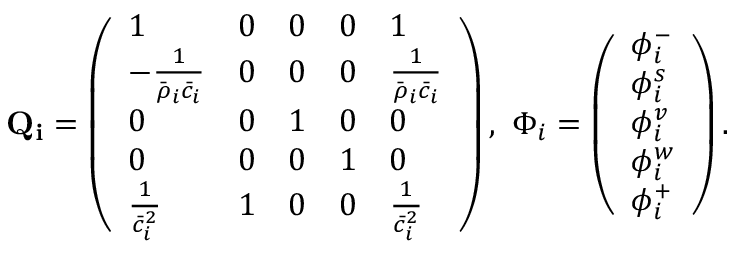<formula> <loc_0><loc_0><loc_500><loc_500>Q _ { i } = \left ( \begin{array} { l l l l l } { 1 } & { 0 } & { 0 } & { 0 } & { 1 } \\ { - \frac { 1 } { \bar { \rho } _ { i } \bar { c } _ { i } } } & { 0 } & { 0 } & { 0 } & { \frac { 1 } { \bar { \rho } _ { i } \bar { c } _ { i } } } \\ { 0 } & { 0 } & { 1 } & { 0 } & { 0 } \\ { 0 } & { 0 } & { 0 } & { 1 } & { 0 } \\ { \frac { 1 } { \bar { c } _ { i } ^ { 2 } } } & { 1 } & { 0 } & { 0 } & { \frac { 1 } { \bar { c } _ { i } ^ { 2 } } } \end{array} \right ) , \ \Phi _ { i } = \left ( \begin{array} { l } { \phi _ { i } ^ { - } } \\ { \phi _ { i } ^ { s } } \\ { \phi _ { i } ^ { v } } \\ { \phi _ { i } ^ { w } } \\ { \phi _ { i } ^ { + } } \end{array} \right ) .</formula> 